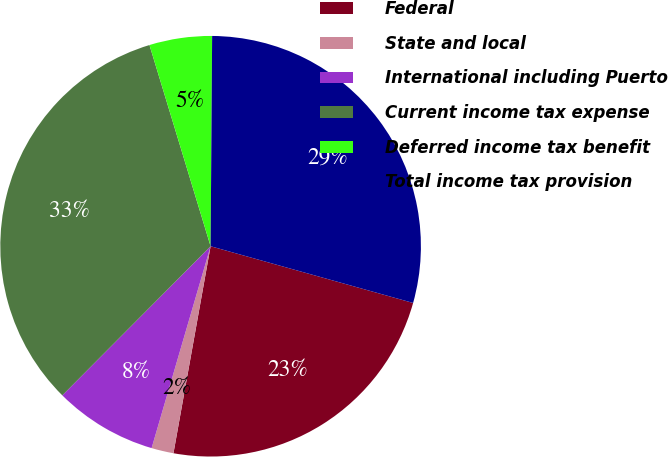<chart> <loc_0><loc_0><loc_500><loc_500><pie_chart><fcel>Federal<fcel>State and local<fcel>International including Puerto<fcel>Current income tax expense<fcel>Deferred income tax benefit<fcel>Total income tax provision<nl><fcel>23.48%<fcel>1.7%<fcel>7.93%<fcel>32.85%<fcel>4.81%<fcel>29.23%<nl></chart> 